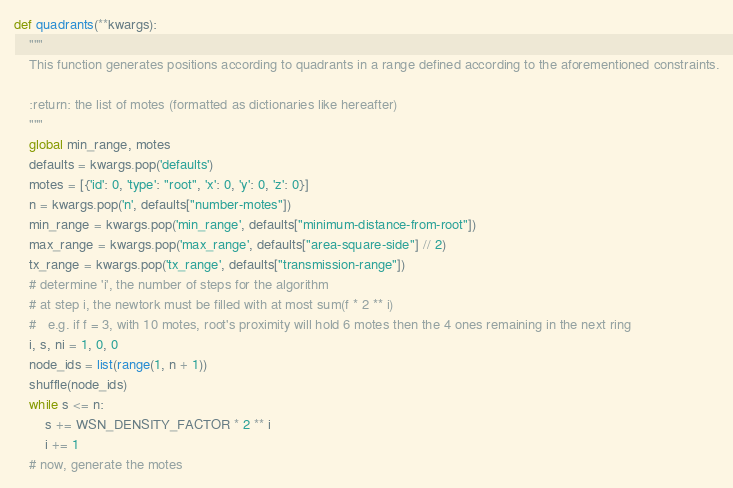Convert code to text. <code><loc_0><loc_0><loc_500><loc_500><_Python_>def quadrants(**kwargs):
    """
    This function generates positions according to quadrants in a range defined according to the aforementioned constraints.

    :return: the list of motes (formatted as dictionaries like hereafter)
    """
    global min_range, motes
    defaults = kwargs.pop('defaults')
    motes = [{'id': 0, 'type': "root", 'x': 0, 'y': 0, 'z': 0}]
    n = kwargs.pop('n', defaults["number-motes"])
    min_range = kwargs.pop('min_range', defaults["minimum-distance-from-root"])
    max_range = kwargs.pop('max_range', defaults["area-square-side"] // 2)
    tx_range = kwargs.pop('tx_range', defaults["transmission-range"])
    # determine 'i', the number of steps for the algorithm
    # at step i, the newtork must be filled with at most sum(f * 2 ** i)
    #   e.g. if f = 3, with 10 motes, root's proximity will hold 6 motes then the 4 ones remaining in the next ring
    i, s, ni = 1, 0, 0
    node_ids = list(range(1, n + 1))
    shuffle(node_ids)
    while s <= n:
        s += WSN_DENSITY_FACTOR * 2 ** i
        i += 1
    # now, generate the motes</code> 